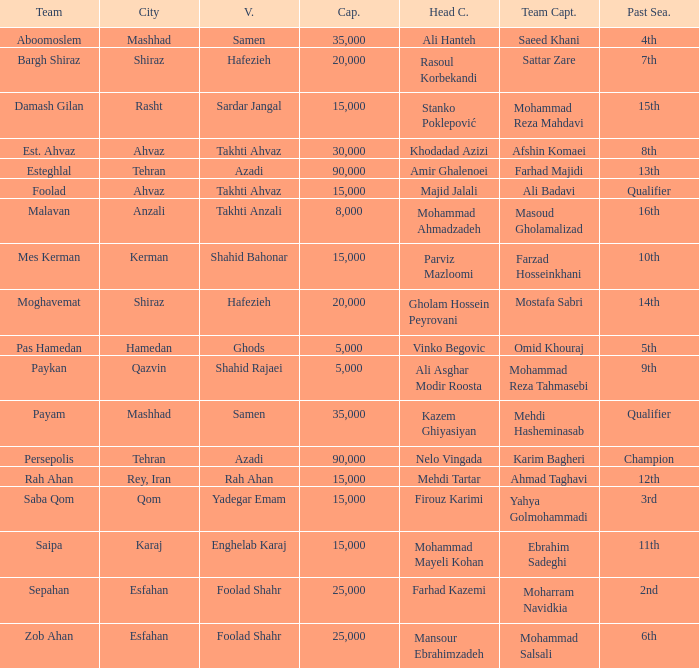Would you be able to parse every entry in this table? {'header': ['Team', 'City', 'V.', 'Cap.', 'Head C.', 'Team Capt.', 'Past Sea.'], 'rows': [['Aboomoslem', 'Mashhad', 'Samen', '35,000', 'Ali Hanteh', 'Saeed Khani', '4th'], ['Bargh Shiraz', 'Shiraz', 'Hafezieh', '20,000', 'Rasoul Korbekandi', 'Sattar Zare', '7th'], ['Damash Gilan', 'Rasht', 'Sardar Jangal', '15,000', 'Stanko Poklepović', 'Mohammad Reza Mahdavi', '15th'], ['Est. Ahvaz', 'Ahvaz', 'Takhti Ahvaz', '30,000', 'Khodadad Azizi', 'Afshin Komaei', '8th'], ['Esteghlal', 'Tehran', 'Azadi', '90,000', 'Amir Ghalenoei', 'Farhad Majidi', '13th'], ['Foolad', 'Ahvaz', 'Takhti Ahvaz', '15,000', 'Majid Jalali', 'Ali Badavi', 'Qualifier'], ['Malavan', 'Anzali', 'Takhti Anzali', '8,000', 'Mohammad Ahmadzadeh', 'Masoud Gholamalizad', '16th'], ['Mes Kerman', 'Kerman', 'Shahid Bahonar', '15,000', 'Parviz Mazloomi', 'Farzad Hosseinkhani', '10th'], ['Moghavemat', 'Shiraz', 'Hafezieh', '20,000', 'Gholam Hossein Peyrovani', 'Mostafa Sabri', '14th'], ['Pas Hamedan', 'Hamedan', 'Ghods', '5,000', 'Vinko Begovic', 'Omid Khouraj', '5th'], ['Paykan', 'Qazvin', 'Shahid Rajaei', '5,000', 'Ali Asghar Modir Roosta', 'Mohammad Reza Tahmasebi', '9th'], ['Payam', 'Mashhad', 'Samen', '35,000', 'Kazem Ghiyasiyan', 'Mehdi Hasheminasab', 'Qualifier'], ['Persepolis', 'Tehran', 'Azadi', '90,000', 'Nelo Vingada', 'Karim Bagheri', 'Champion'], ['Rah Ahan', 'Rey, Iran', 'Rah Ahan', '15,000', 'Mehdi Tartar', 'Ahmad Taghavi', '12th'], ['Saba Qom', 'Qom', 'Yadegar Emam', '15,000', 'Firouz Karimi', 'Yahya Golmohammadi', '3rd'], ['Saipa', 'Karaj', 'Enghelab Karaj', '15,000', 'Mohammad Mayeli Kohan', 'Ebrahim Sadeghi', '11th'], ['Sepahan', 'Esfahan', 'Foolad Shahr', '25,000', 'Farhad Kazemi', 'Moharram Navidkia', '2nd'], ['Zob Ahan', 'Esfahan', 'Foolad Shahr', '25,000', 'Mansour Ebrahimzadeh', 'Mohammad Salsali', '6th']]} What Venue has a Past Season of 2nd? Foolad Shahr. 